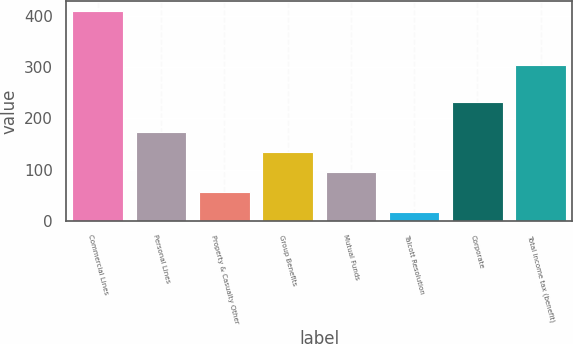Convert chart to OTSL. <chart><loc_0><loc_0><loc_500><loc_500><bar_chart><fcel>Commercial Lines<fcel>Personal Lines<fcel>Property & Casualty Other<fcel>Group Benefits<fcel>Mutual Funds<fcel>Talcott Resolution<fcel>Corporate<fcel>Total income tax (benefit)<nl><fcel>409<fcel>173.8<fcel>56.2<fcel>134.6<fcel>95.4<fcel>17<fcel>233<fcel>305<nl></chart> 